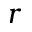Convert formula to latex. <formula><loc_0><loc_0><loc_500><loc_500>r</formula> 